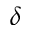<formula> <loc_0><loc_0><loc_500><loc_500>\delta</formula> 